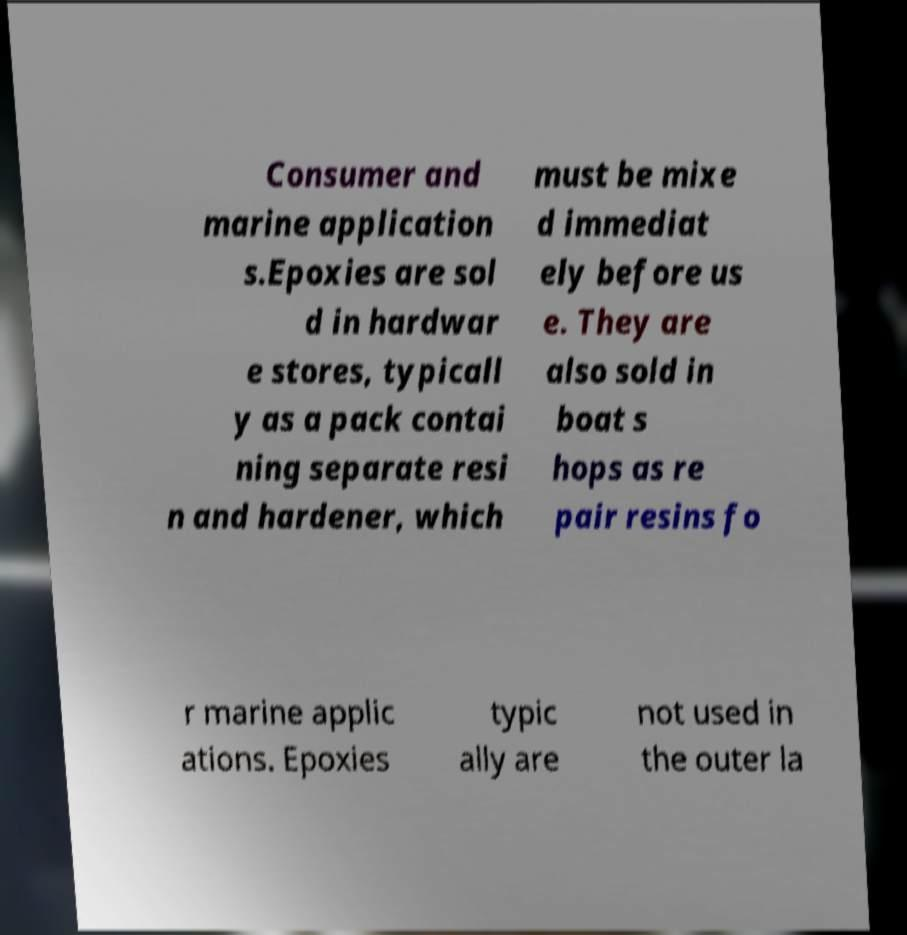Please read and relay the text visible in this image. What does it say? Consumer and marine application s.Epoxies are sol d in hardwar e stores, typicall y as a pack contai ning separate resi n and hardener, which must be mixe d immediat ely before us e. They are also sold in boat s hops as re pair resins fo r marine applic ations. Epoxies typic ally are not used in the outer la 